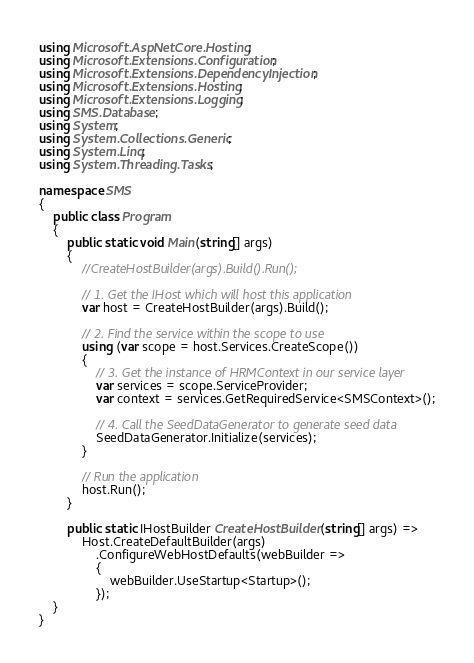<code> <loc_0><loc_0><loc_500><loc_500><_C#_>using Microsoft.AspNetCore.Hosting;
using Microsoft.Extensions.Configuration;
using Microsoft.Extensions.DependencyInjection;
using Microsoft.Extensions.Hosting;
using Microsoft.Extensions.Logging;
using SMS.Database;
using System;
using System.Collections.Generic;
using System.Linq;
using System.Threading.Tasks;

namespace SMS
{
    public class Program
    {
        public static void Main(string[] args)
        {
            //CreateHostBuilder(args).Build().Run();

            // 1. Get the IHost which will host this application
            var host = CreateHostBuilder(args).Build();

            // 2. Find the service within the scope to use
            using (var scope = host.Services.CreateScope())
            {
                // 3. Get the instance of HRMContext in our service layer
                var services = scope.ServiceProvider;
                var context = services.GetRequiredService<SMSContext>();

                // 4. Call the SeedDataGenerator to generate seed data
                SeedDataGenerator.Initialize(services);
            }

            // Run the application 
            host.Run();
        }

        public static IHostBuilder CreateHostBuilder(string[] args) =>
            Host.CreateDefaultBuilder(args)
                .ConfigureWebHostDefaults(webBuilder =>
                {
                    webBuilder.UseStartup<Startup>();
                });
    }
}
</code> 